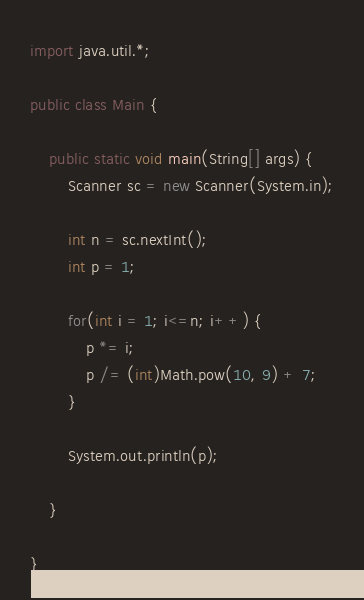<code> <loc_0><loc_0><loc_500><loc_500><_Java_>import java.util.*;

public class Main {

	public static void main(String[] args) {
		Scanner sc = new Scanner(System.in);
		
		int n = sc.nextInt();
		int p = 1;
		
		for(int i = 1; i<=n; i++) {
			p *= i;
			p /= (int)Math.pow(10, 9) + 7;
		}
		
		System.out.println(p);

	}

}</code> 